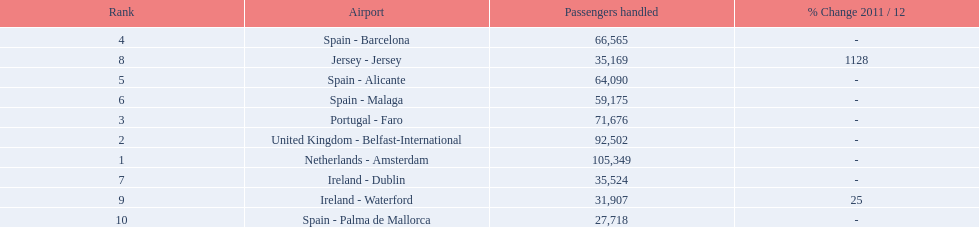What are all of the destinations out of the london southend airport? Netherlands - Amsterdam, United Kingdom - Belfast-International, Portugal - Faro, Spain - Barcelona, Spain - Alicante, Spain - Malaga, Ireland - Dublin, Jersey - Jersey, Ireland - Waterford, Spain - Palma de Mallorca. How many passengers has each destination handled? 105,349, 92,502, 71,676, 66,565, 64,090, 59,175, 35,524, 35,169, 31,907, 27,718. And of those, which airport handled the fewest passengers? Spain - Palma de Mallorca. 